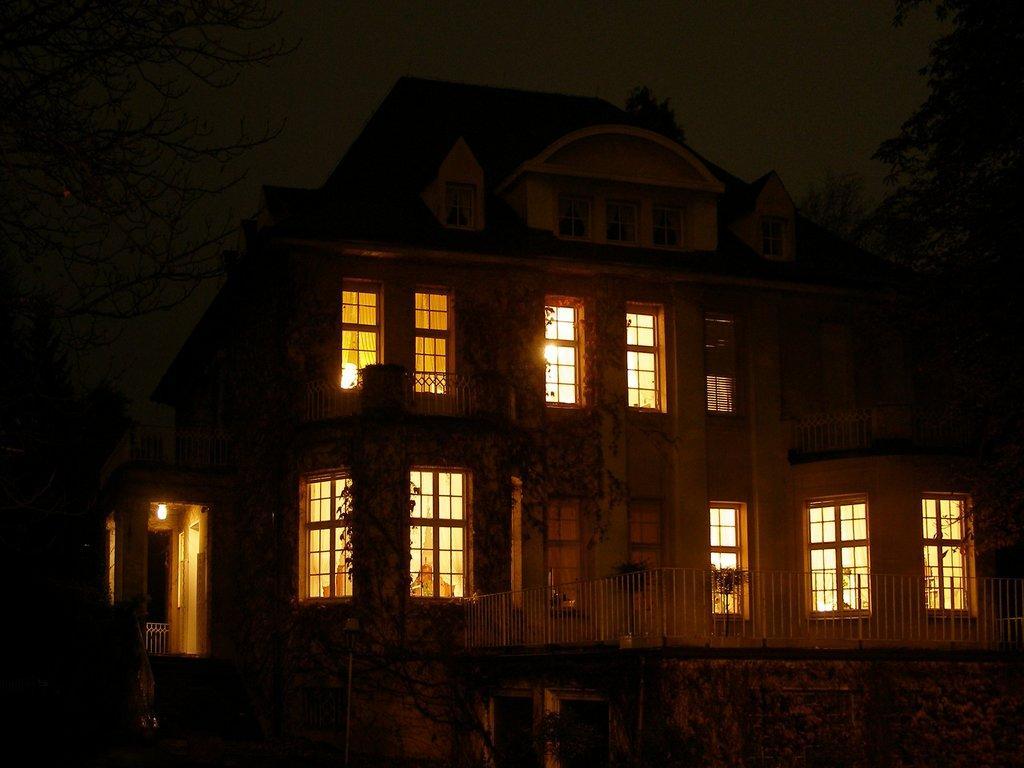How would you summarize this image in a sentence or two? In the picture we can see a night view of the building with windows to it and from it we can see lights and railing around it and beside the building we can see a tree and behind it we can see a sky. 